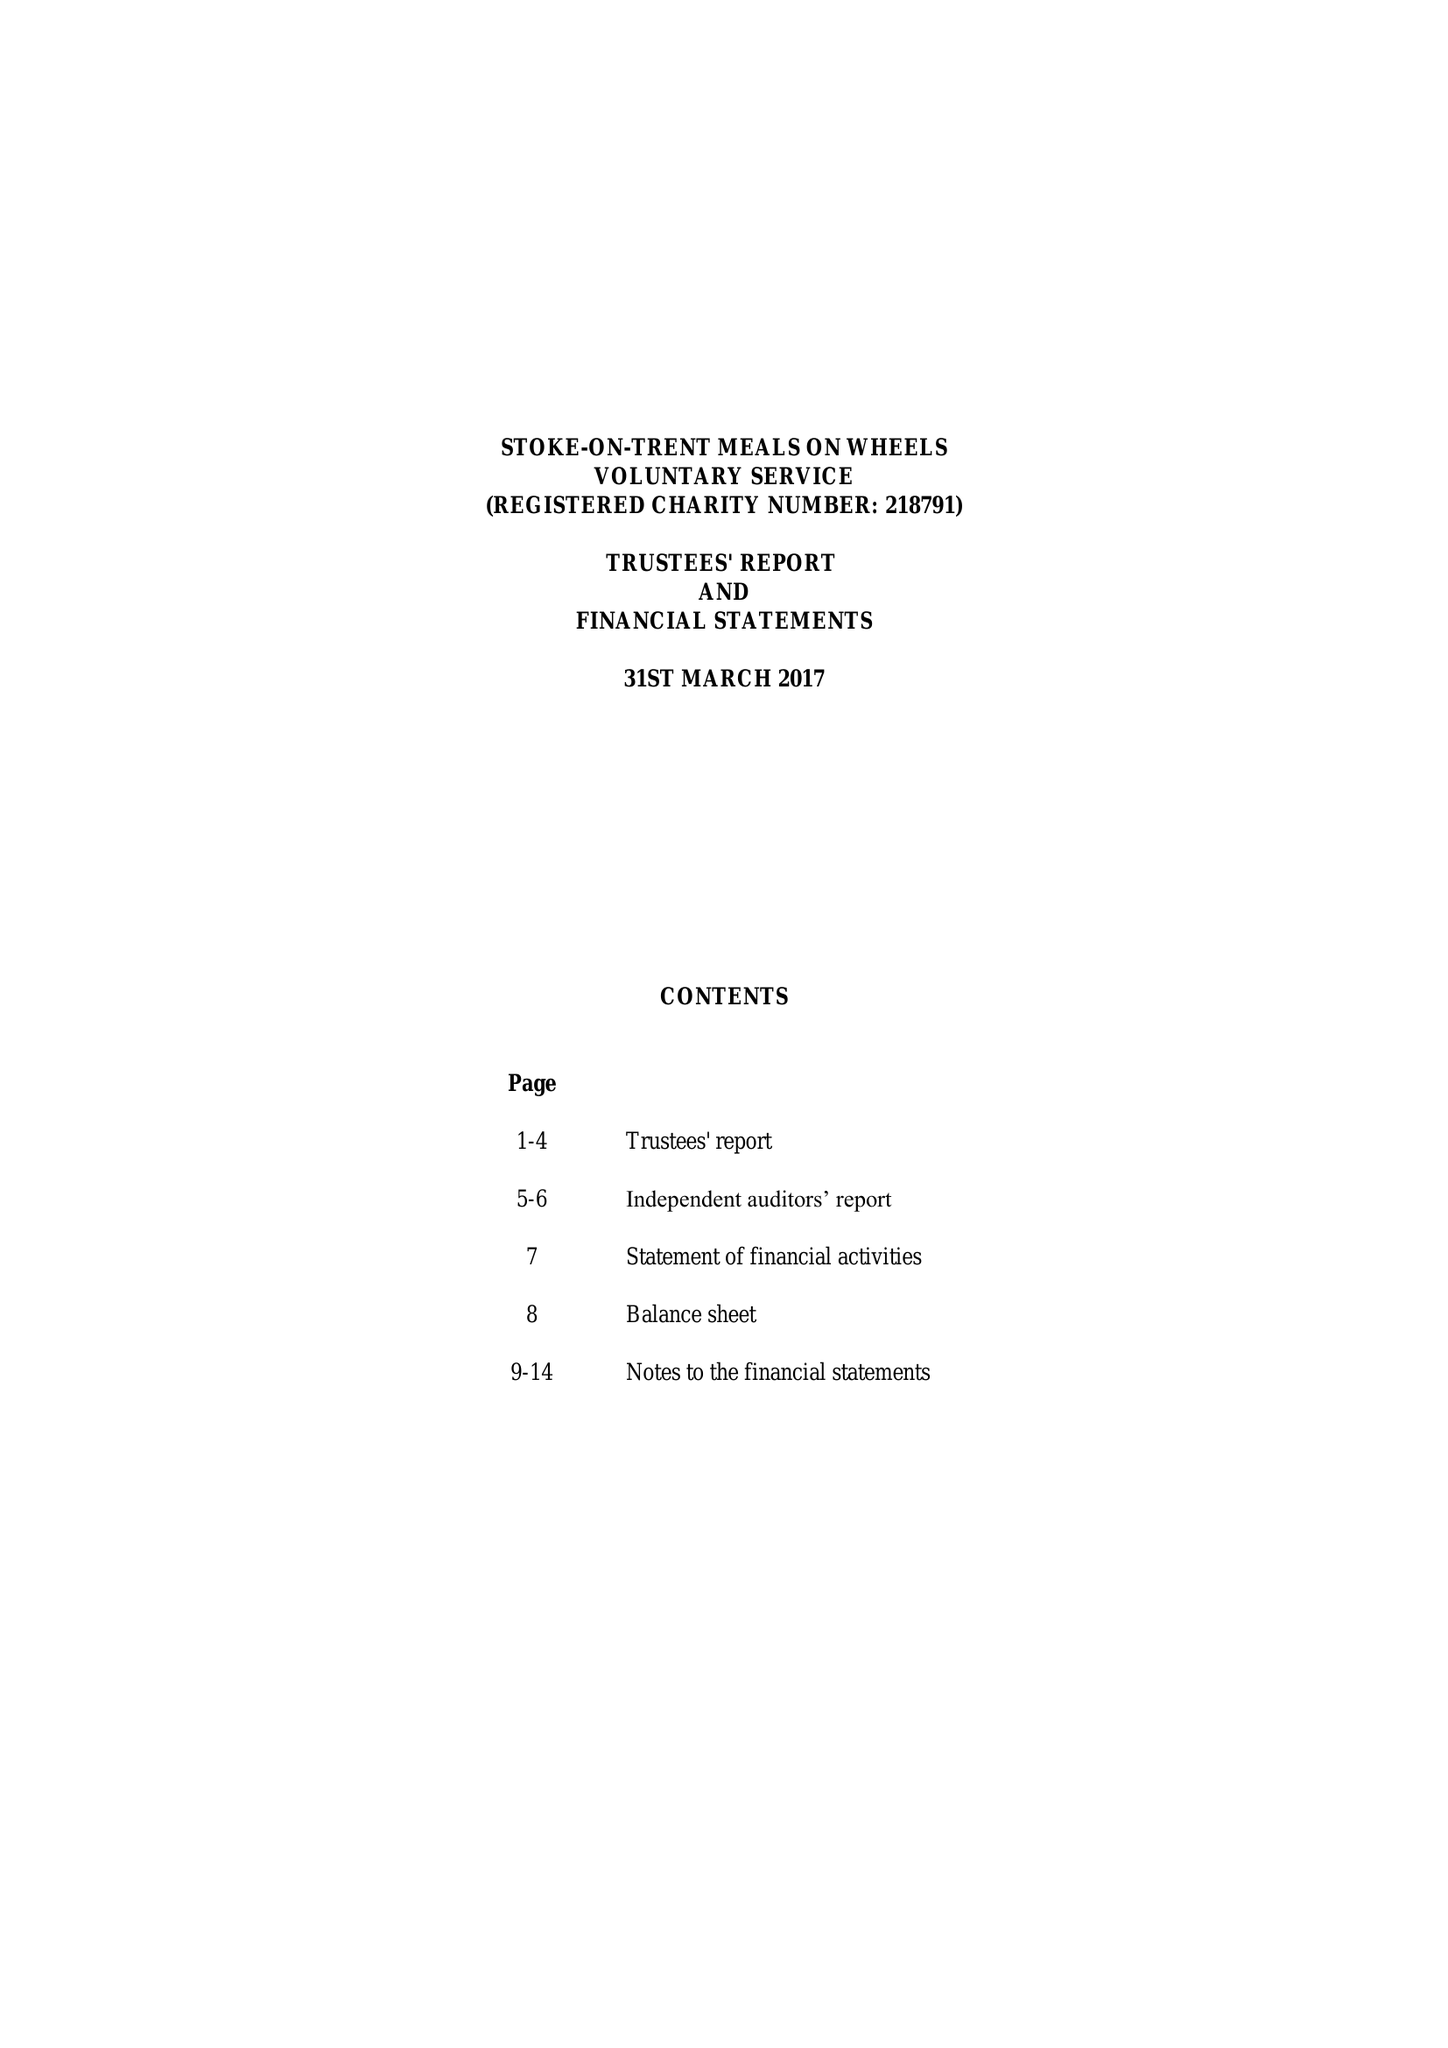What is the value for the address__post_town?
Answer the question using a single word or phrase. STOKE-ON-TRENT 